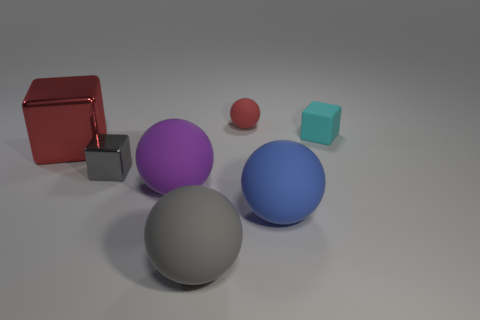There is a small object that is on the left side of the thing that is behind the cyan cube; what number of big red objects are behind it?
Your answer should be compact. 1. There is a block right of the red rubber sphere; is it the same size as the gray shiny cube?
Ensure brevity in your answer.  Yes. Is the number of large rubber things on the left side of the small cyan thing less than the number of large blue balls behind the big red shiny object?
Your response must be concise. No. Does the tiny rubber block have the same color as the large metallic block?
Give a very brief answer. No. Is the number of red metallic things that are to the left of the large purple rubber thing less than the number of small red things?
Your answer should be compact. No. What material is the sphere that is the same color as the big shiny object?
Your answer should be compact. Rubber. Does the gray sphere have the same material as the purple ball?
Offer a terse response. Yes. How many other gray cubes are made of the same material as the gray block?
Make the answer very short. 0. The block that is the same material as the gray ball is what color?
Offer a terse response. Cyan. What is the shape of the large red object?
Your response must be concise. Cube. 